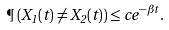<formula> <loc_0><loc_0><loc_500><loc_500>\P \left ( X _ { 1 } ( t ) \not = X _ { 2 } ( t ) \right ) \leq c e ^ { - \beta t } .</formula> 